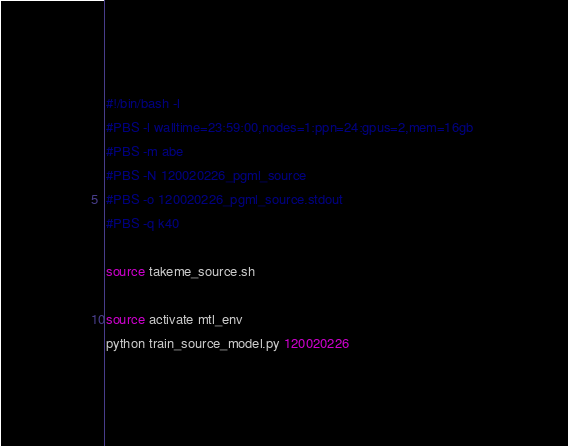Convert code to text. <code><loc_0><loc_0><loc_500><loc_500><_Bash_>#!/bin/bash -l
#PBS -l walltime=23:59:00,nodes=1:ppn=24:gpus=2,mem=16gb 
#PBS -m abe 
#PBS -N 120020226_pgml_source 
#PBS -o 120020226_pgml_source.stdout 
#PBS -q k40 

source takeme_source.sh

source activate mtl_env
python train_source_model.py 120020226</code> 